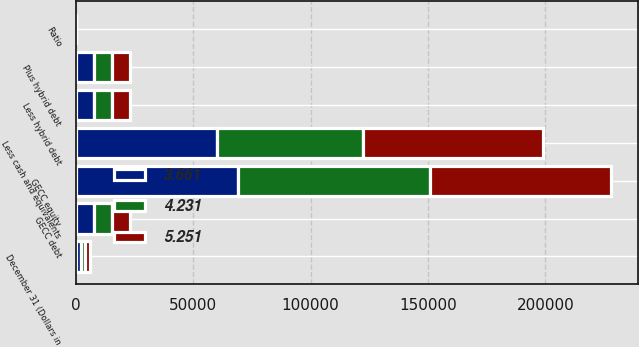Convert chart. <chart><loc_0><loc_0><loc_500><loc_500><stacked_bar_chart><ecel><fcel>December 31 (Dollars in<fcel>GECC debt<fcel>Less cash and equivalents<fcel>Less hybrid debt<fcel>GECC equity<fcel>Plus hybrid debt<fcel>Ratio<nl><fcel>4.231<fcel>2012<fcel>7725<fcel>61941<fcel>7725<fcel>81890<fcel>7725<fcel>3.66<nl><fcel>5.251<fcel>2011<fcel>7725<fcel>76702<fcel>7725<fcel>77110<fcel>7725<fcel>4.23<nl><fcel>3.661<fcel>2010<fcel>7725<fcel>60257<fcel>7725<fcel>68984<fcel>7725<fcel>5.25<nl></chart> 